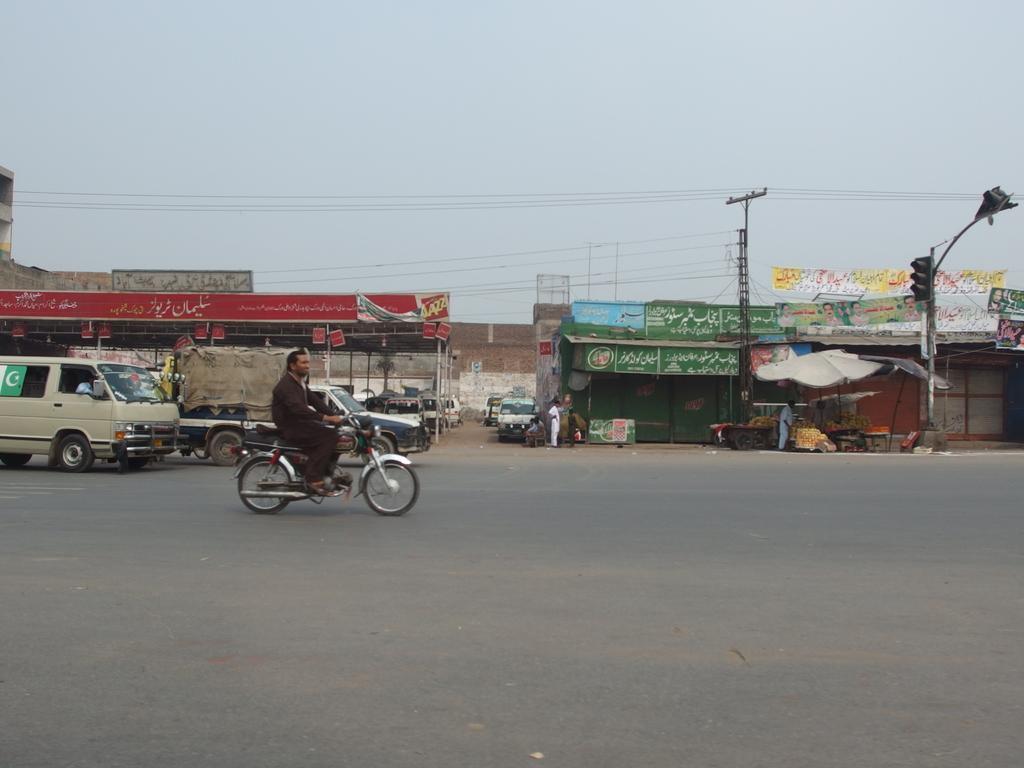Describe this image in one or two sentences. In this image I can see the road. On the road I can see many vehicles. I can see one person riding the motorbike. In the background I can see many sheds and the boards to it. In-front of the sheds I can see the poles. I can also see the sky in the back. 